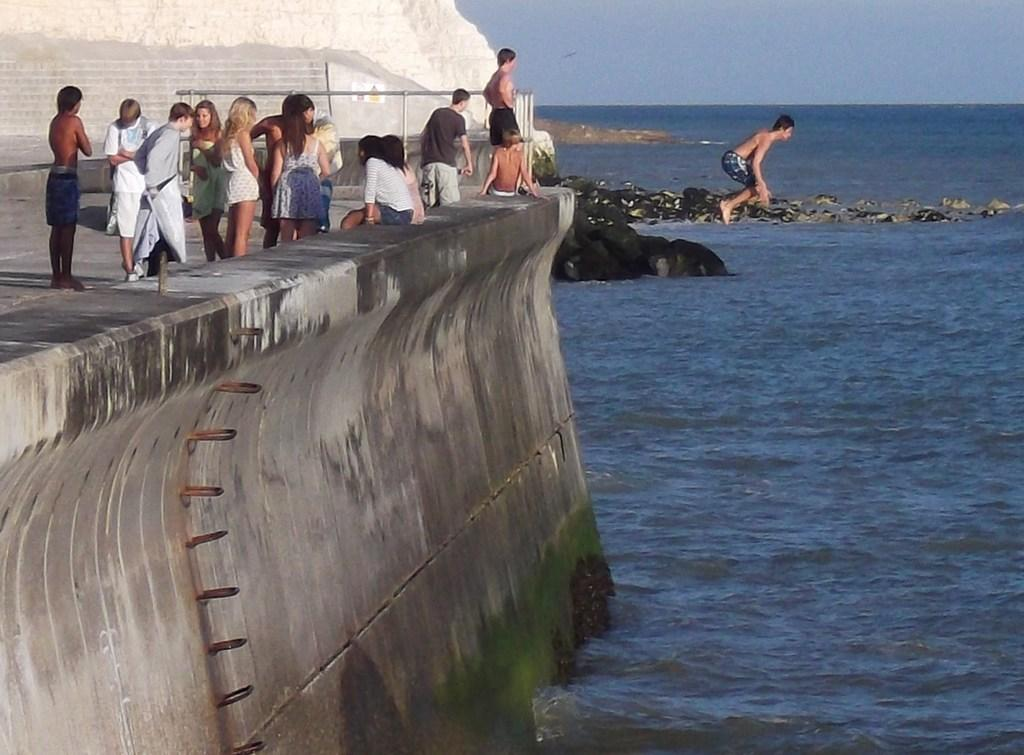What is happening with the group of people in the image? There is a group of people standing in the image. What action is being performed by one of the individuals in the image? There is a man jumping in the image. What natural element is present in the image? There is water visible in the image. What type of terrain can be seen in the image? There are rocks in the image. What is visible at the top of the image? The sky is visible at the top of the image. What type of noise can be heard coming from the rocks in the image? There is no indication of any noise in the image, as it is a still photograph. What time of day is depicted in the image? The time of day cannot be determined from the image alone, as there are no specific clues or indicators present. 